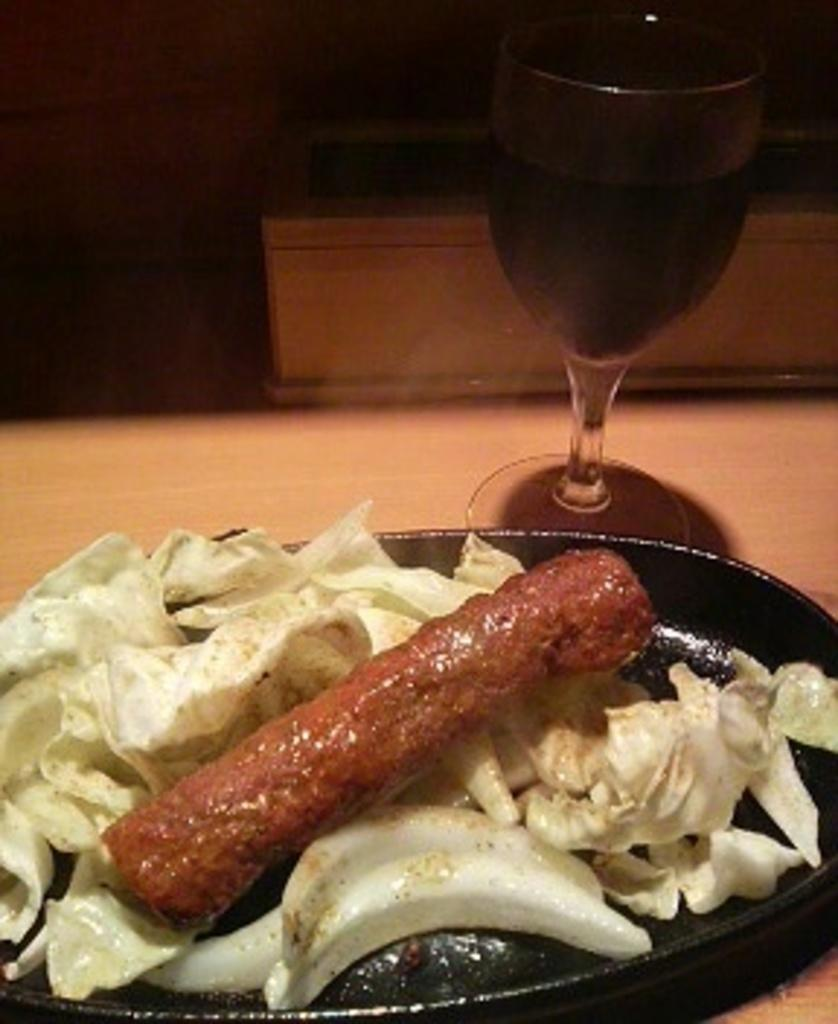Where was the image taken? The image is taken indoors. What furniture is present in the image? There is a table in the image. What beverage is visible on the table? There is a glass of wine on the table. What type of food can be seen on the table? There is a plate with a food item on the table. What type of tree is visible through the window in the image? There is no window or tree visible in the image; it is taken indoors. 